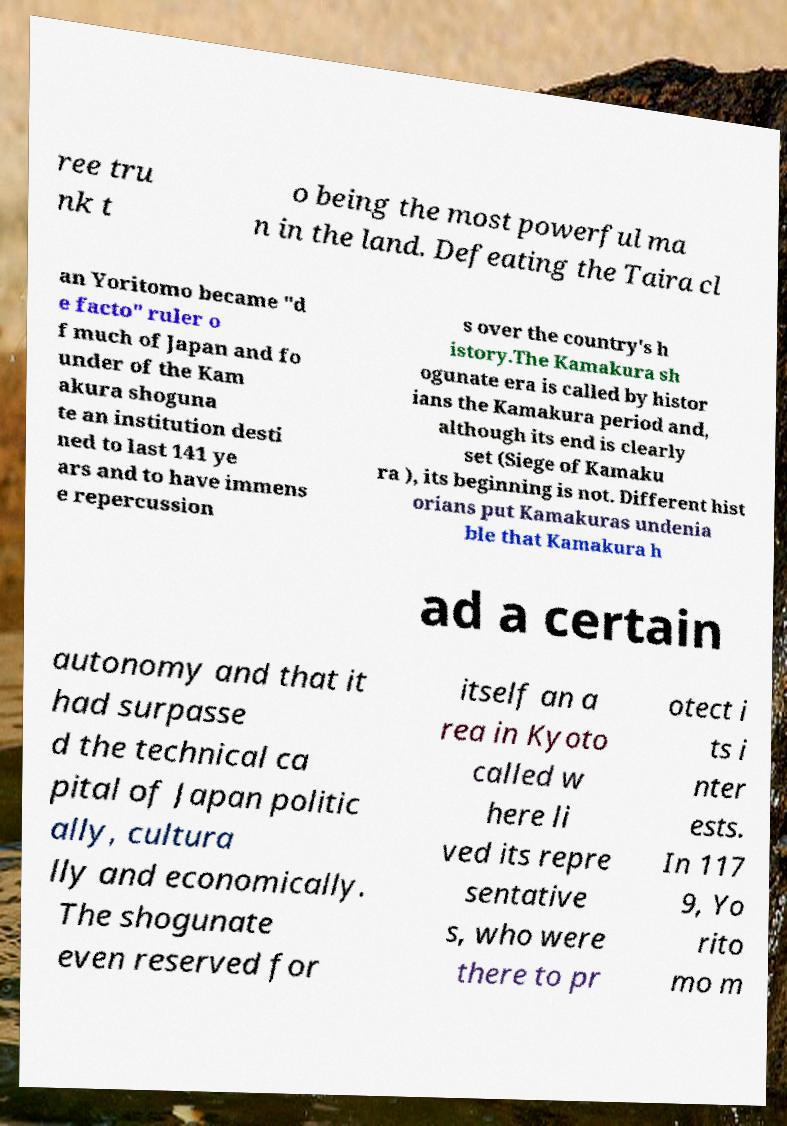Could you assist in decoding the text presented in this image and type it out clearly? ree tru nk t o being the most powerful ma n in the land. Defeating the Taira cl an Yoritomo became "d e facto" ruler o f much of Japan and fo under of the Kam akura shoguna te an institution desti ned to last 141 ye ars and to have immens e repercussion s over the country's h istory.The Kamakura sh ogunate era is called by histor ians the Kamakura period and, although its end is clearly set (Siege of Kamaku ra ), its beginning is not. Different hist orians put Kamakuras undenia ble that Kamakura h ad a certain autonomy and that it had surpasse d the technical ca pital of Japan politic ally, cultura lly and economically. The shogunate even reserved for itself an a rea in Kyoto called w here li ved its repre sentative s, who were there to pr otect i ts i nter ests. In 117 9, Yo rito mo m 